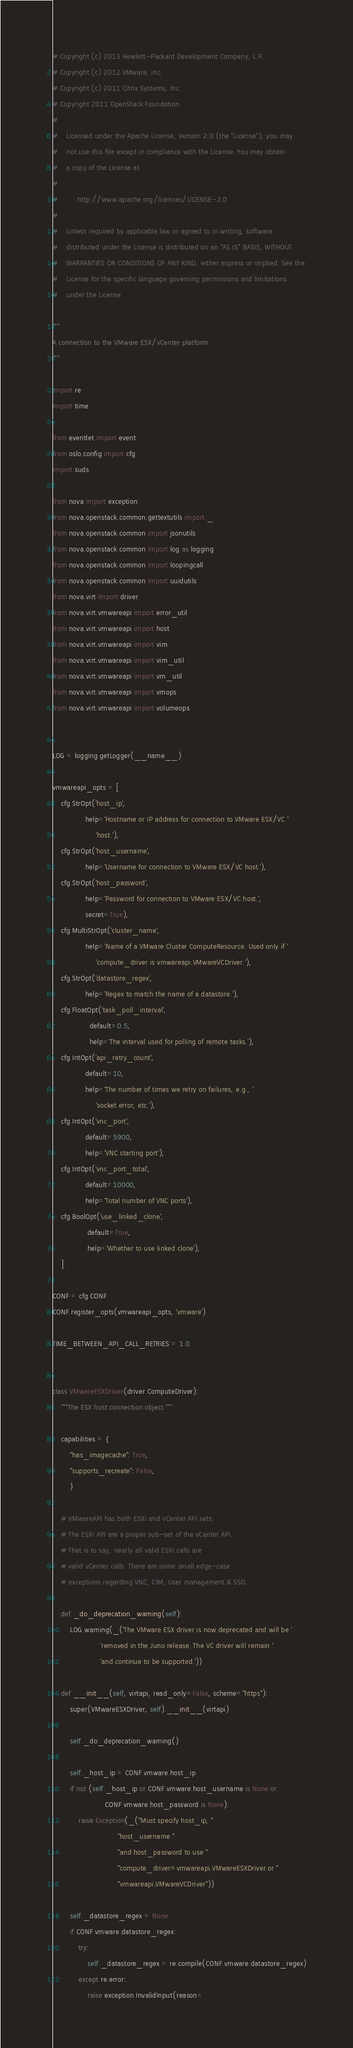Convert code to text. <code><loc_0><loc_0><loc_500><loc_500><_Python_># Copyright (c) 2013 Hewlett-Packard Development Company, L.P.
# Copyright (c) 2012 VMware, Inc.
# Copyright (c) 2011 Citrix Systems, Inc.
# Copyright 2011 OpenStack Foundation
#
#    Licensed under the Apache License, Version 2.0 (the "License"); you may
#    not use this file except in compliance with the License. You may obtain
#    a copy of the License at
#
#         http://www.apache.org/licenses/LICENSE-2.0
#
#    Unless required by applicable law or agreed to in writing, software
#    distributed under the License is distributed on an "AS IS" BASIS, WITHOUT
#    WARRANTIES OR CONDITIONS OF ANY KIND, either express or implied. See the
#    License for the specific language governing permissions and limitations
#    under the License.

"""
A connection to the VMware ESX/vCenter platform.
"""

import re
import time

from eventlet import event
from oslo.config import cfg
import suds

from nova import exception
from nova.openstack.common.gettextutils import _
from nova.openstack.common import jsonutils
from nova.openstack.common import log as logging
from nova.openstack.common import loopingcall
from nova.openstack.common import uuidutils
from nova.virt import driver
from nova.virt.vmwareapi import error_util
from nova.virt.vmwareapi import host
from nova.virt.vmwareapi import vim
from nova.virt.vmwareapi import vim_util
from nova.virt.vmwareapi import vm_util
from nova.virt.vmwareapi import vmops
from nova.virt.vmwareapi import volumeops


LOG = logging.getLogger(__name__)

vmwareapi_opts = [
    cfg.StrOpt('host_ip',
               help='Hostname or IP address for connection to VMware ESX/VC '
                    'host.'),
    cfg.StrOpt('host_username',
               help='Username for connection to VMware ESX/VC host.'),
    cfg.StrOpt('host_password',
               help='Password for connection to VMware ESX/VC host.',
               secret=True),
    cfg.MultiStrOpt('cluster_name',
               help='Name of a VMware Cluster ComputeResource. Used only if '
                    'compute_driver is vmwareapi.VMwareVCDriver.'),
    cfg.StrOpt('datastore_regex',
               help='Regex to match the name of a datastore.'),
    cfg.FloatOpt('task_poll_interval',
                 default=0.5,
                 help='The interval used for polling of remote tasks.'),
    cfg.IntOpt('api_retry_count',
               default=10,
               help='The number of times we retry on failures, e.g., '
                    'socket error, etc.'),
    cfg.IntOpt('vnc_port',
               default=5900,
               help='VNC starting port'),
    cfg.IntOpt('vnc_port_total',
               default=10000,
               help='Total number of VNC ports'),
    cfg.BoolOpt('use_linked_clone',
                default=True,
                help='Whether to use linked clone'),
    ]

CONF = cfg.CONF
CONF.register_opts(vmwareapi_opts, 'vmware')

TIME_BETWEEN_API_CALL_RETRIES = 1.0


class VMwareESXDriver(driver.ComputeDriver):
    """The ESX host connection object."""

    capabilities = {
        "has_imagecache": True,
        "supports_recreate": False,
        }

    # VMwareAPI has both ESXi and vCenter API sets.
    # The ESXi API are a proper sub-set of the vCenter API.
    # That is to say, nearly all valid ESXi calls are
    # valid vCenter calls. There are some small edge-case
    # exceptions regarding VNC, CIM, User management & SSO.

    def _do_deprecation_warning(self):
        LOG.warning(_('The VMware ESX driver is now deprecated and will be '
                      'removed in the Juno release. The VC driver will remain '
                      'and continue to be supported.'))

    def __init__(self, virtapi, read_only=False, scheme="https"):
        super(VMwareESXDriver, self).__init__(virtapi)

        self._do_deprecation_warning()

        self._host_ip = CONF.vmware.host_ip
        if not (self._host_ip or CONF.vmware.host_username is None or
                        CONF.vmware.host_password is None):
            raise Exception(_("Must specify host_ip, "
                              "host_username "
                              "and host_password to use "
                              "compute_driver=vmwareapi.VMwareESXDriver or "
                              "vmwareapi.VMwareVCDriver"))

        self._datastore_regex = None
        if CONF.vmware.datastore_regex:
            try:
                self._datastore_regex = re.compile(CONF.vmware.datastore_regex)
            except re.error:
                raise exception.InvalidInput(reason=</code> 